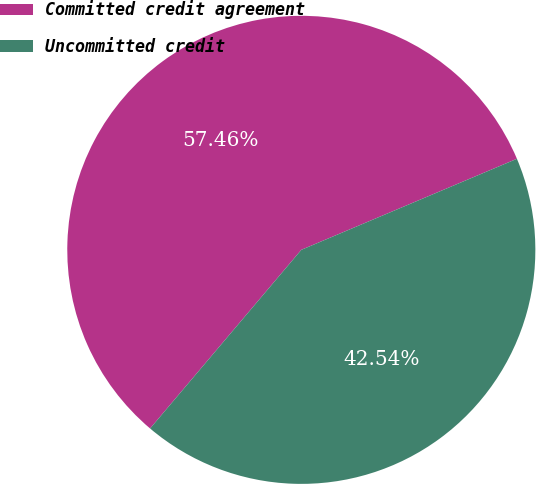Convert chart. <chart><loc_0><loc_0><loc_500><loc_500><pie_chart><fcel>Committed credit agreement<fcel>Uncommitted credit<nl><fcel>57.46%<fcel>42.54%<nl></chart> 